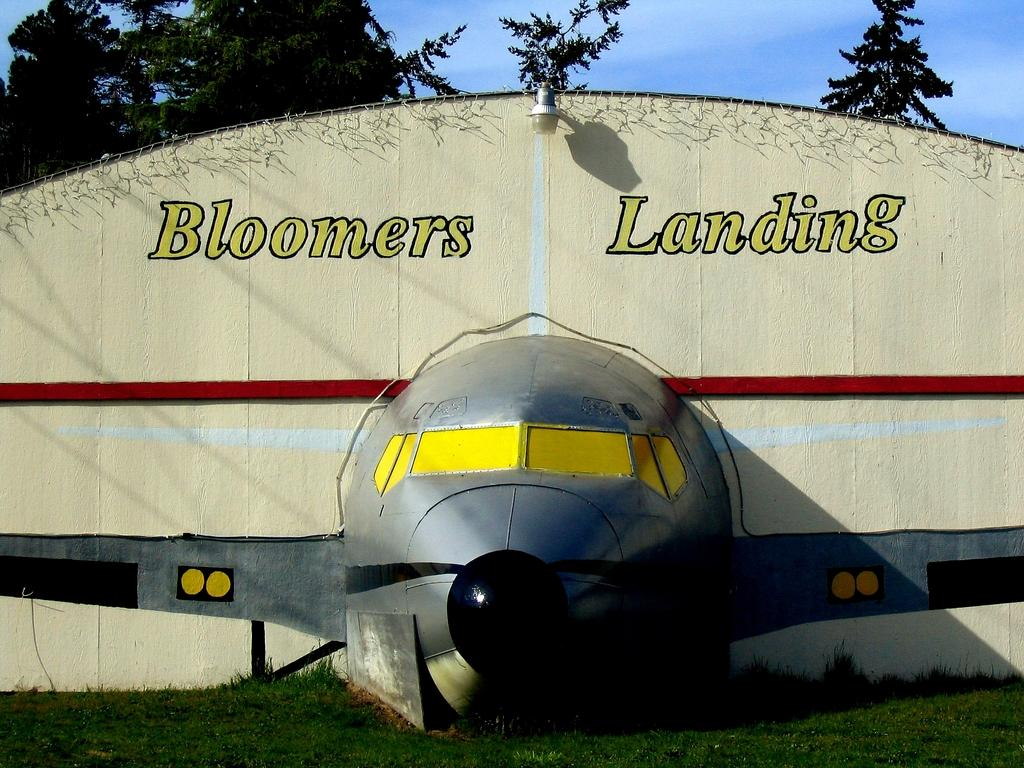<image>
Summarize the visual content of the image. A sign for Bloomers Landing has the front of a plane sticking out of it. 